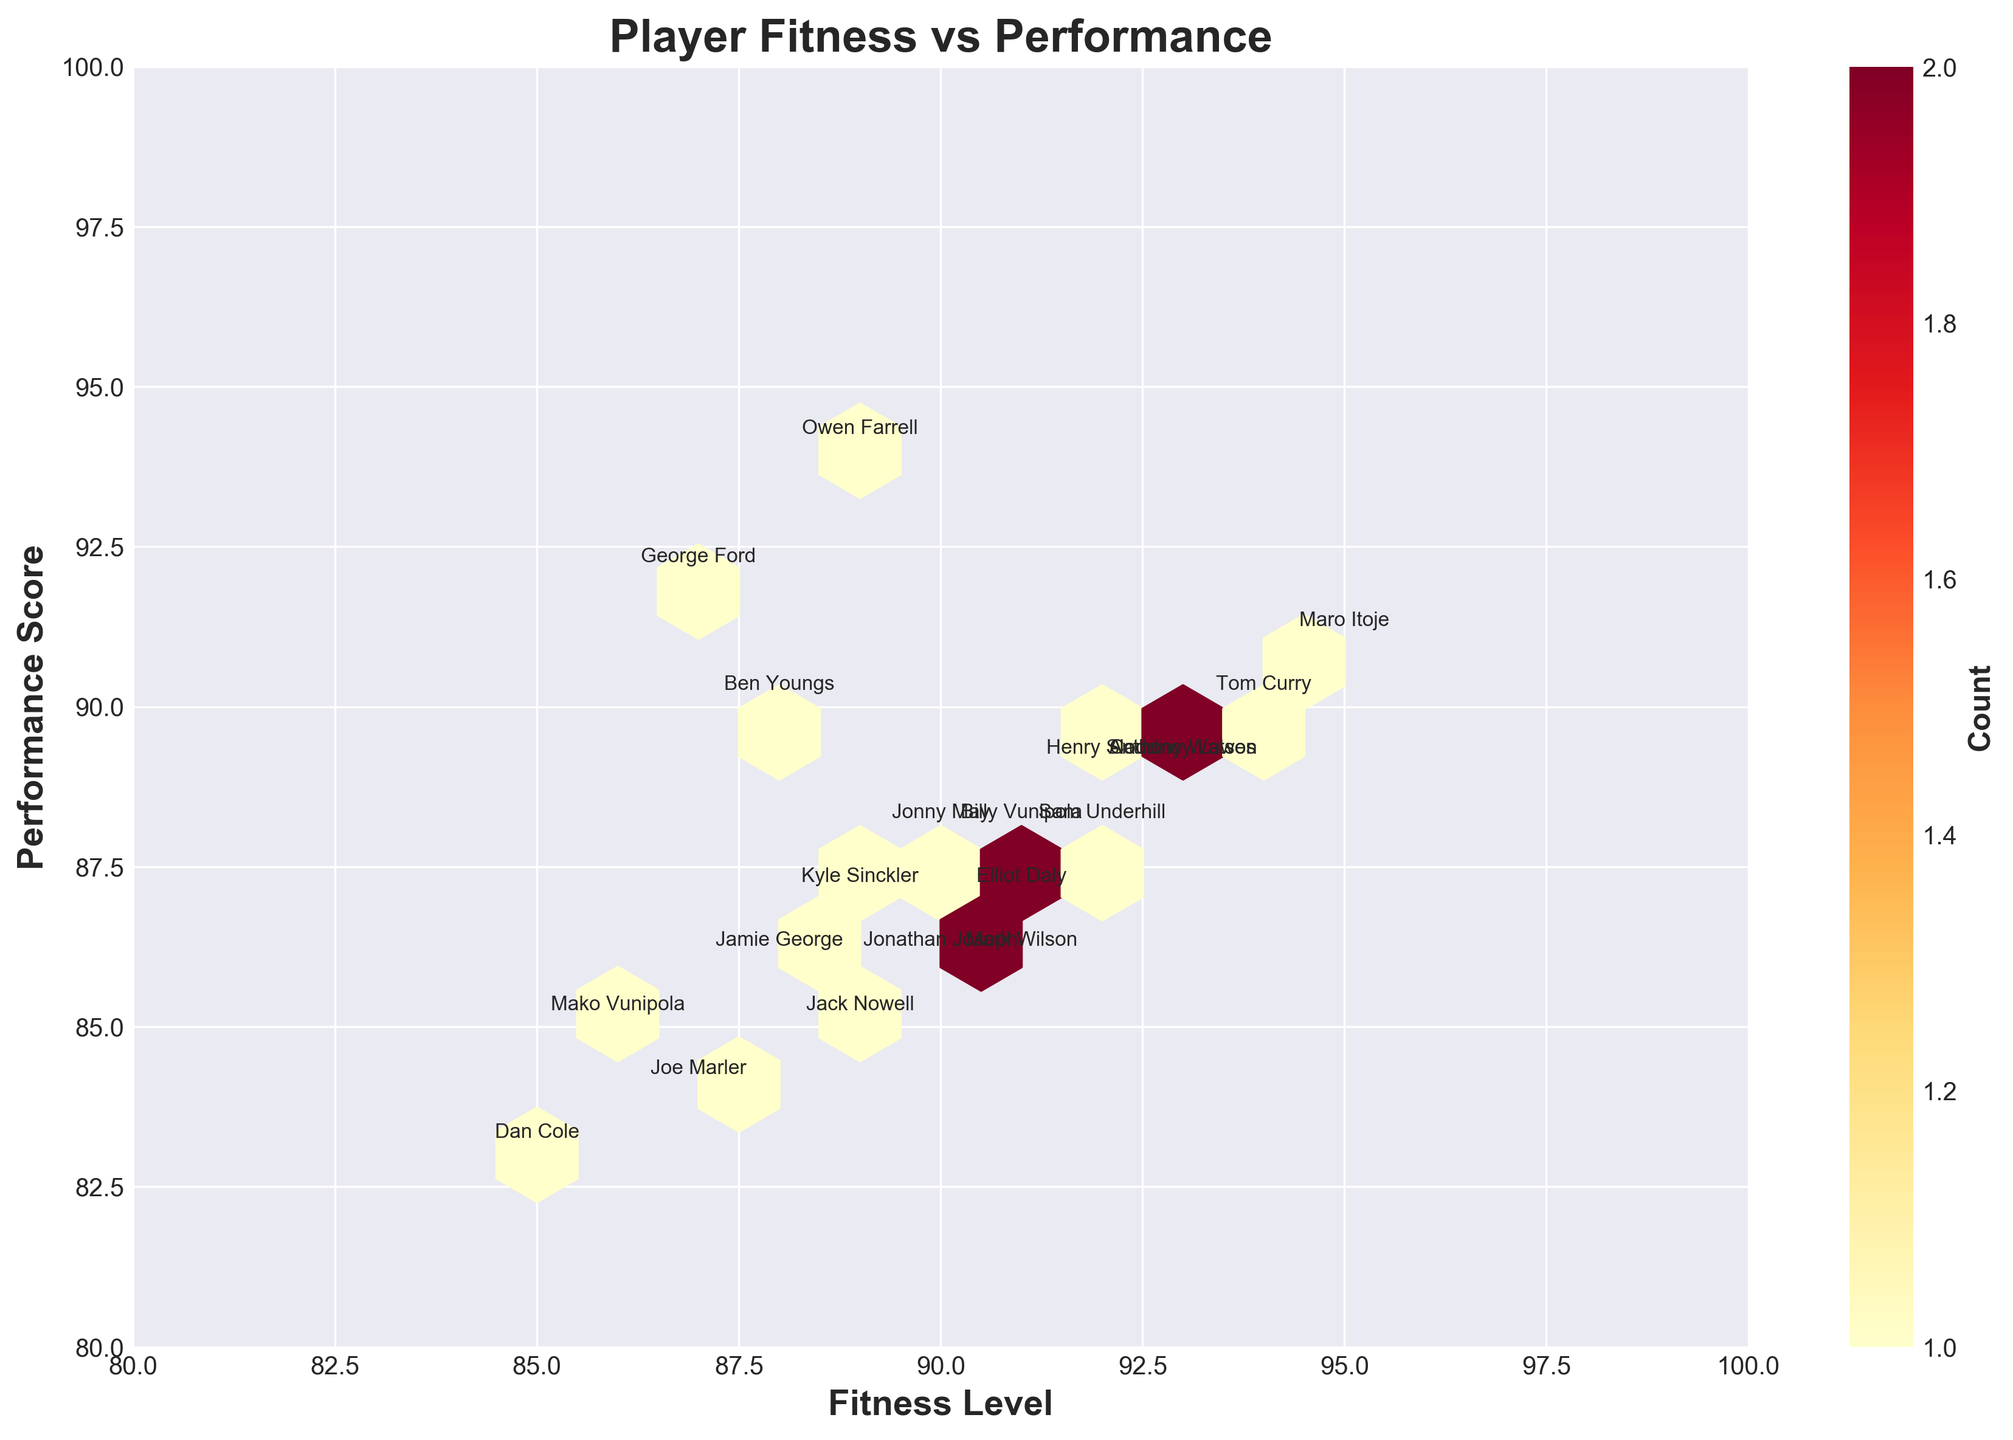What's the title of the hexbin plot? The title of a plot can usually be found at the top center of the figure. In this case, it reads "Player Fitness vs Performance".
Answer: Player Fitness vs Performance What are the x and y-axis labels? The axis labels provide information about what the axes represent. The x-axis is labeled 'Fitness Level', and the y-axis is labeled 'Performance Score'.
Answer: Fitness Level and Performance Score How many data points are displayed in the plot? Each hexagon represents one or more data points. The plot contains annotations for 20 players, indicating there are 20 data points.
Answer: 20 Which player has the highest performance score? By looking at the y-axis (Performance Score) and the data points, Owen Farrell has the highest performance score with a value of 94.
Answer: Owen Farrell What is the highest fitness level noted on the plot? Maro Itoje has the highest fitness level recorded at 95, which can be seen by examining the x-axis values.
Answer: 95 Who has a fitness level of 88 and what is their performance score? Observing the hexagon where the fitness level is 88, Jamie George has a fitness level of 88 and a performance score of 86.
Answer: Jamie George, 86 Which player combines a fitness level of 87 with a performance score above 90? Searching in the plot for a point where fitness level is 87 and performance score is above 90, this matches George Ford who has a performance score of 92.
Answer: George Ford How many hexagons have a 'count' of more than one player? A hexbin plot uses color intensity to show density. The color bar indicates higher counts. There are no hexagons dark enough to indicate more than one player, shown by light color shades.
Answer: 0 What is the average fitness level and performance score of the team? Add all the fitness levels and performance scores, then divide by the number of players: Fitness = (92+95+89+91+93+88+94+90+87+86+89+92+91+87+85+88+90+89+93+91)/20, Performance = (88+91+94+87+89+86+90+88+92+85+87+89+88+84+83+90+86+85+89+86)/20. Performing the calculations: Sum fitness = 1822, Sum performance = 1747, Average fitness = 91.1, Average performance = 87.35.
Answer: 91.1 and 87.35 